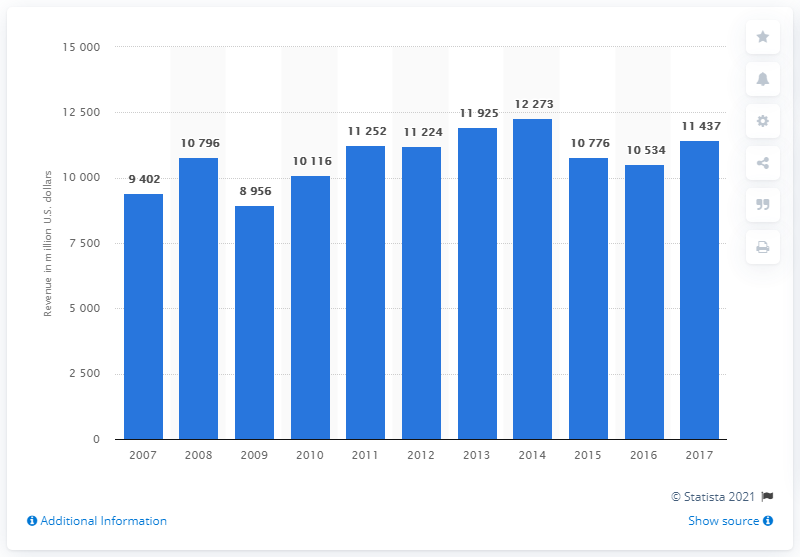Indicate a few pertinent items in this graphic. In 2017, Praxair generated approximately $114,370 in revenue. 